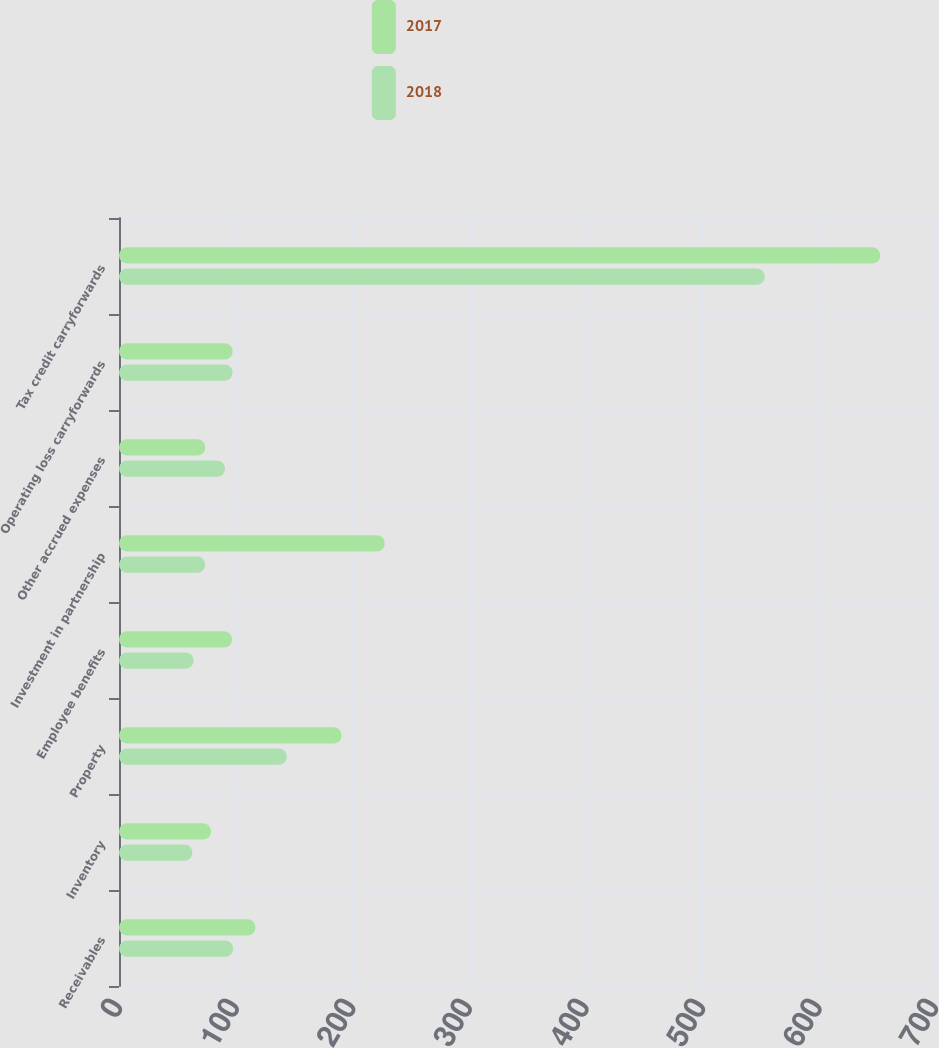<chart> <loc_0><loc_0><loc_500><loc_500><stacked_bar_chart><ecel><fcel>Receivables<fcel>Inventory<fcel>Property<fcel>Employee benefits<fcel>Investment in partnership<fcel>Other accrued expenses<fcel>Operating loss carryforwards<fcel>Tax credit carryforwards<nl><fcel>2017<fcel>117<fcel>79<fcel>191<fcel>97<fcel>228<fcel>74<fcel>97.5<fcel>653<nl><fcel>2018<fcel>98<fcel>63<fcel>144<fcel>64<fcel>74<fcel>91<fcel>97.5<fcel>554<nl></chart> 